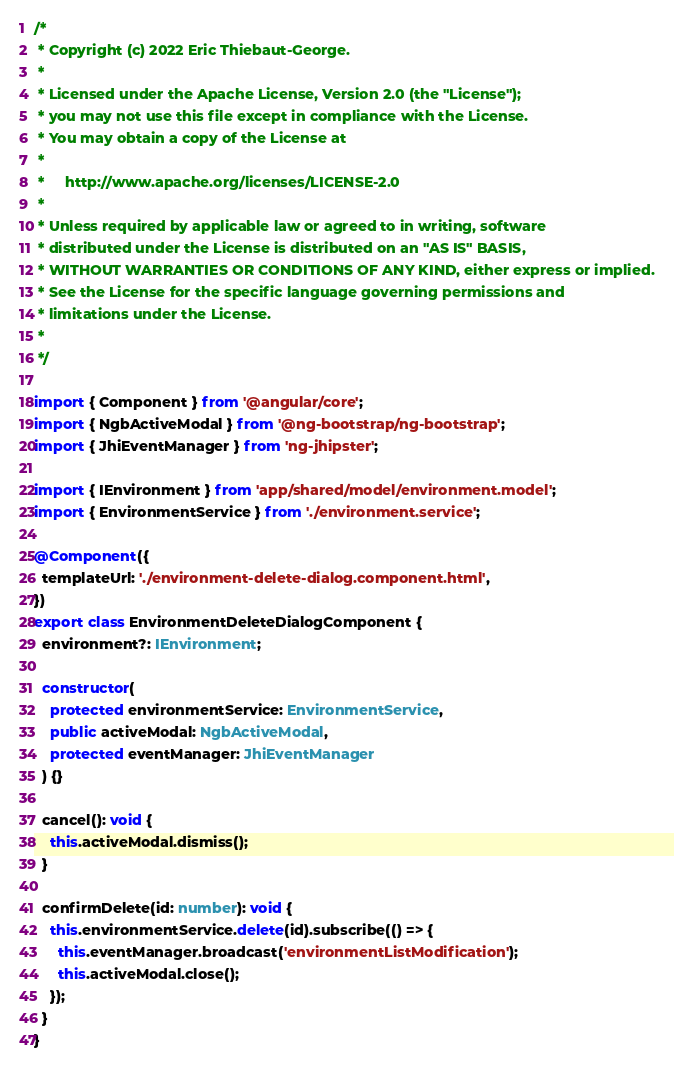<code> <loc_0><loc_0><loc_500><loc_500><_TypeScript_>/*
 * Copyright (c) 2022 Eric Thiebaut-George.
 *
 * Licensed under the Apache License, Version 2.0 (the "License");
 * you may not use this file except in compliance with the License.
 * You may obtain a copy of the License at
 *
 *     http://www.apache.org/licenses/LICENSE-2.0
 *
 * Unless required by applicable law or agreed to in writing, software
 * distributed under the License is distributed on an "AS IS" BASIS,
 * WITHOUT WARRANTIES OR CONDITIONS OF ANY KIND, either express or implied.
 * See the License for the specific language governing permissions and
 * limitations under the License.
 *
 */

import { Component } from '@angular/core';
import { NgbActiveModal } from '@ng-bootstrap/ng-bootstrap';
import { JhiEventManager } from 'ng-jhipster';

import { IEnvironment } from 'app/shared/model/environment.model';
import { EnvironmentService } from './environment.service';

@Component({
  templateUrl: './environment-delete-dialog.component.html',
})
export class EnvironmentDeleteDialogComponent {
  environment?: IEnvironment;

  constructor(
    protected environmentService: EnvironmentService,
    public activeModal: NgbActiveModal,
    protected eventManager: JhiEventManager
  ) {}

  cancel(): void {
    this.activeModal.dismiss();
  }

  confirmDelete(id: number): void {
    this.environmentService.delete(id).subscribe(() => {
      this.eventManager.broadcast('environmentListModification');
      this.activeModal.close();
    });
  }
}
</code> 